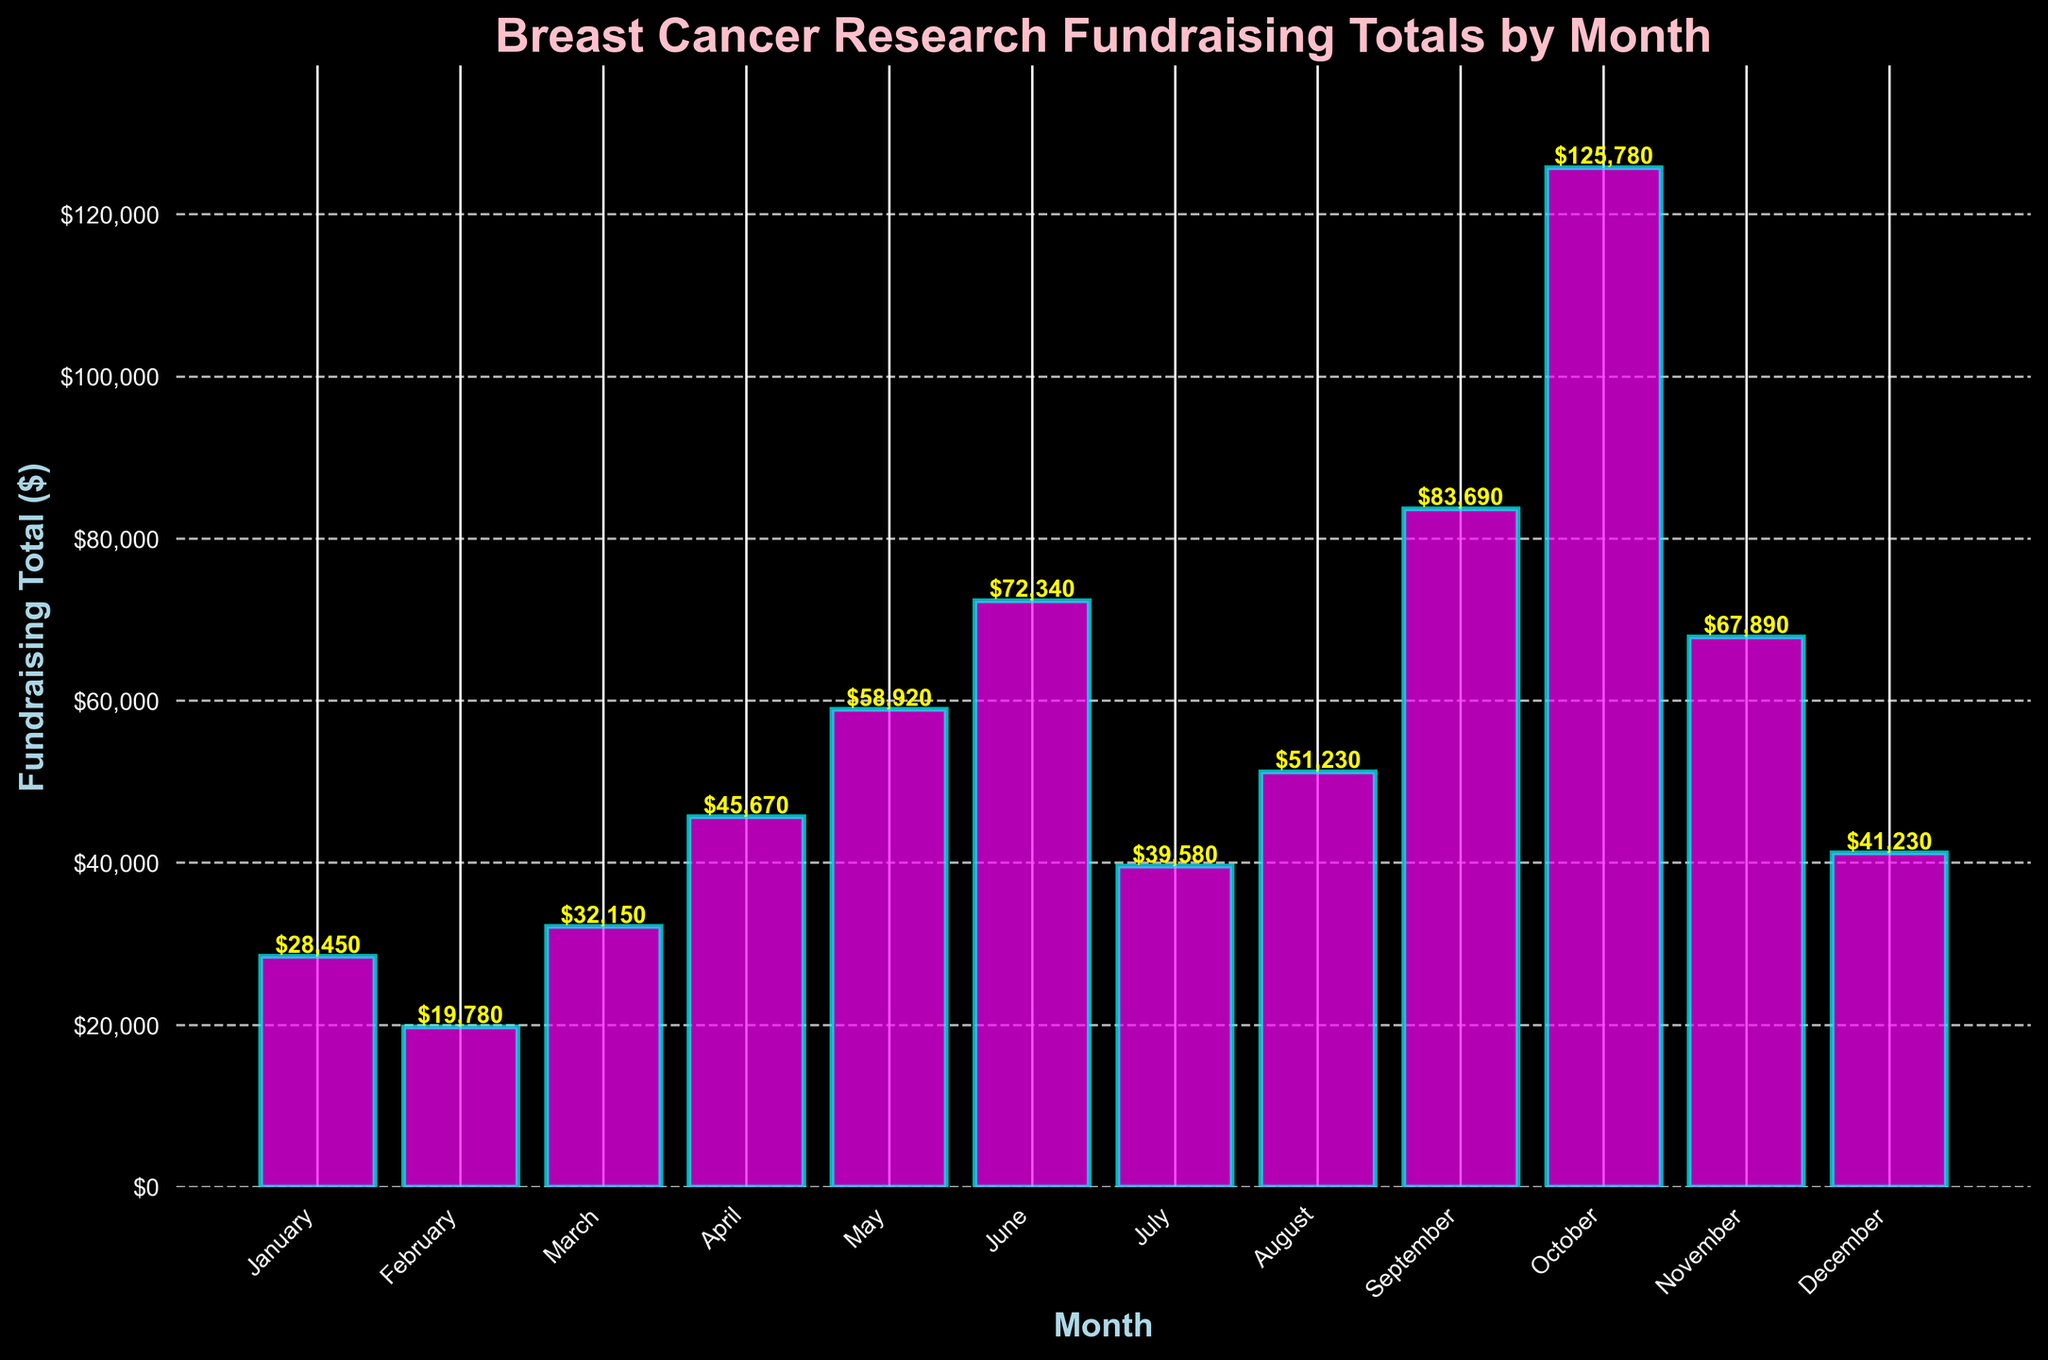Which month had the highest fundraising total? By looking at the height of the bars, October has the tallest bar, indicating it has the highest fundraising total.
Answer: October Which month had the lowest fundraising total? By comparing the height of all the bars, February has the shortest bar, indicating it has the lowest fundraising total.
Answer: February What is the total fundraising amount for the first half of the year? Sum the fundraising totals for January, February, March, April, May, and June: 28450 + 19780 + 32150 + 45670 + 58920 + 72340. The total is 257310.
Answer: 257310 What is the average monthly fundraising total? Sum the fundraising totals for all months and then divide by 12: (28450 + 19780 + 32150 + 45670 + 58920 + 72340 + 39580 + 51230 + 83690 + 125780 + 67890 + 41230) / 12. This equals 633585 / 12 = 52965.42.
Answer: 52965.42 Which month had a fundraising total greater than $50,000 but less than $100,000? By scanning the bars between $50,000 and $100,000, May, June, and September fall in this range.
Answer: May, June, September What is the difference in fundraising totals between the month with the highest total and the month with the lowest total? Subtract the lowest total in February (19780) from the highest total in October (125780): 125780 - 19780. The result is 106000.
Answer: 106000 During which months did the fundraising total exceed the average monthly fundraising total? Calculate the average monthly fundraising total as 52965.42. The months with totals exceeding this average are June, September, October, and November.
Answer: June, September, October, November How much more did October raise than the combined total of January and February? October raised 125780. January and February together raised 28450 + 19780 = 48230. The difference is 125780 - 48230. The result is 77550.
Answer: 77550 What is the combined total fundraising for July, August, and September? Sum the fundraising totals for July, August, and September: 39580 + 51230 + 83690. The total is 174500.
Answer: 174500 